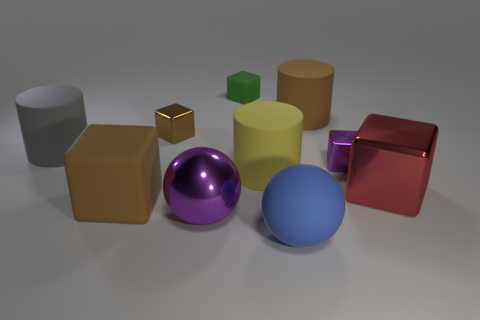Subtract all gray blocks. Subtract all green balls. How many blocks are left? 5 Subtract all cylinders. How many objects are left? 7 Add 5 big brown blocks. How many big brown blocks are left? 6 Add 2 blue things. How many blue things exist? 3 Subtract 0 gray spheres. How many objects are left? 10 Subtract all big red cylinders. Subtract all big brown rubber blocks. How many objects are left? 9 